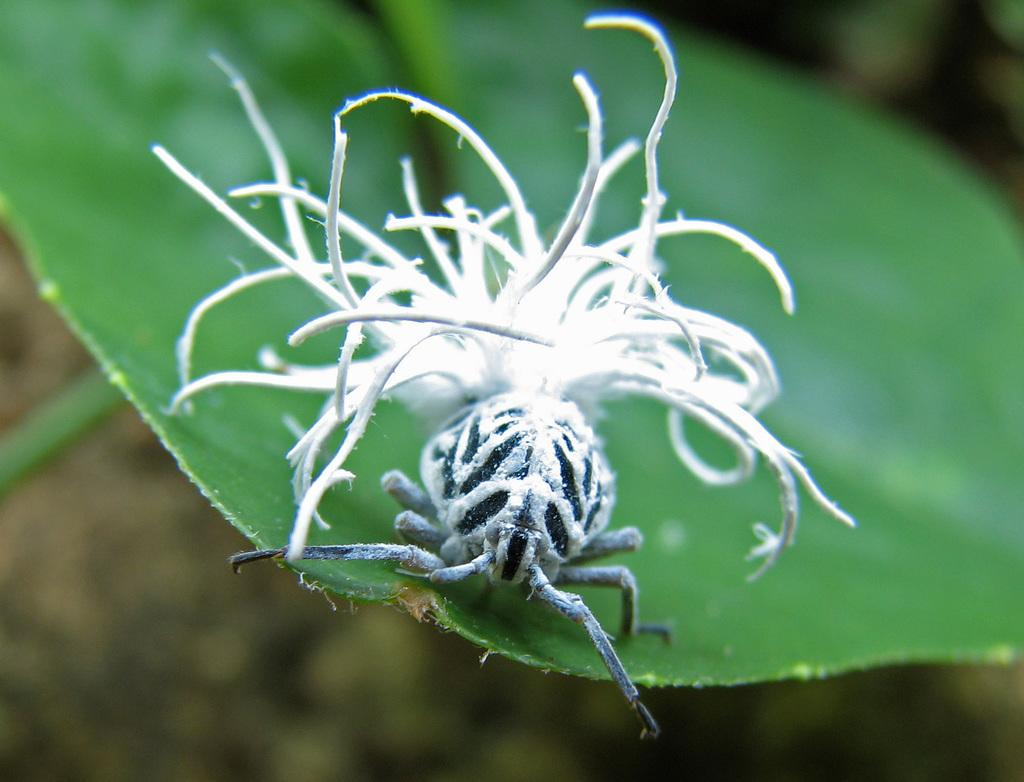What type of creature is in the image? There is a white insect in the image. Where is the insect located? The insect is on a green leaf. What type of belief system does the insect follow in the image? There is no indication of any belief system in the image, as it features a white insect on a green leaf. 